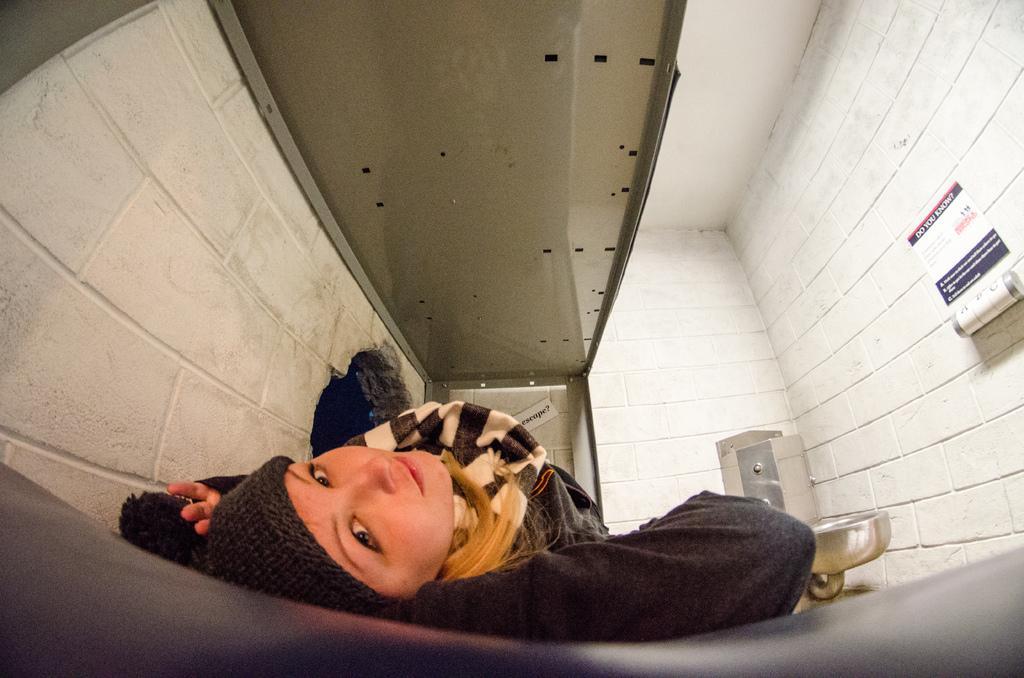How would you summarize this image in a sentence or two? This is the inside picture of the building. In this image there is a person standing beside the shower. In front of her there is a glass door. In the background of the image there is a poster and some object on the wall. At the bottom of the image there is a floor. 